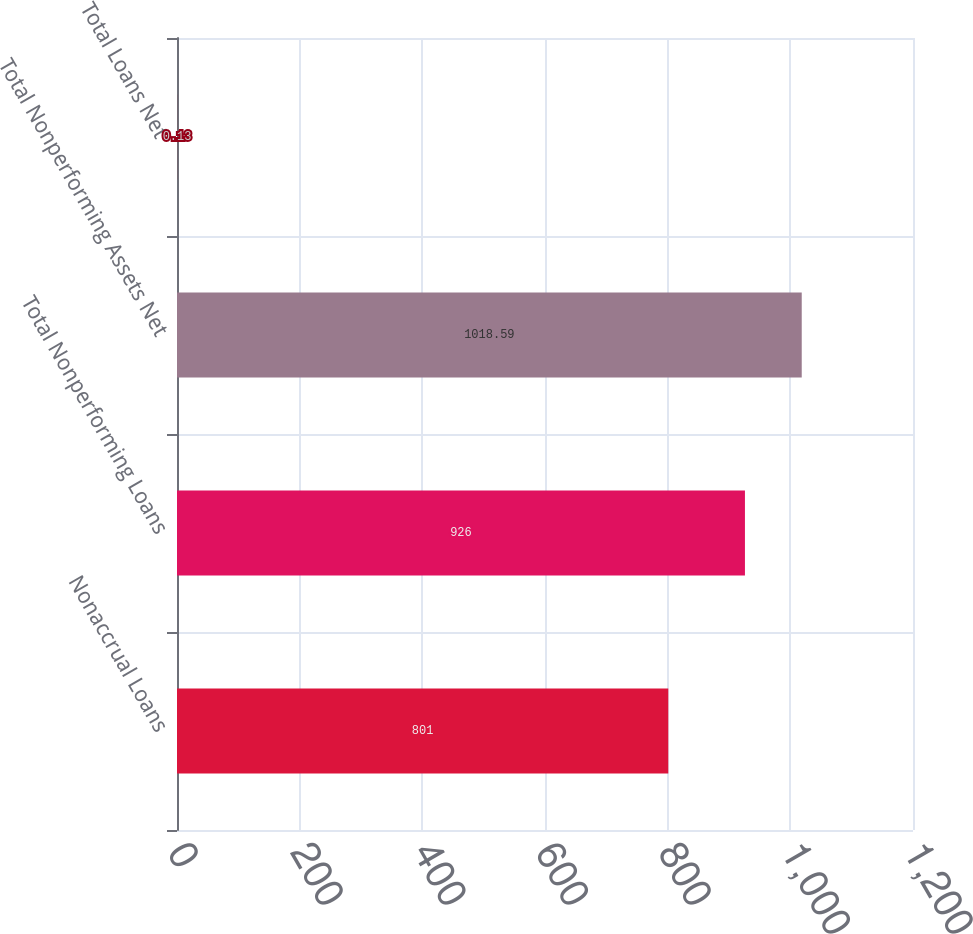Convert chart. <chart><loc_0><loc_0><loc_500><loc_500><bar_chart><fcel>Nonaccrual Loans<fcel>Total Nonperforming Loans<fcel>Total Nonperforming Assets Net<fcel>Total Loans Net<nl><fcel>801<fcel>926<fcel>1018.59<fcel>0.13<nl></chart> 